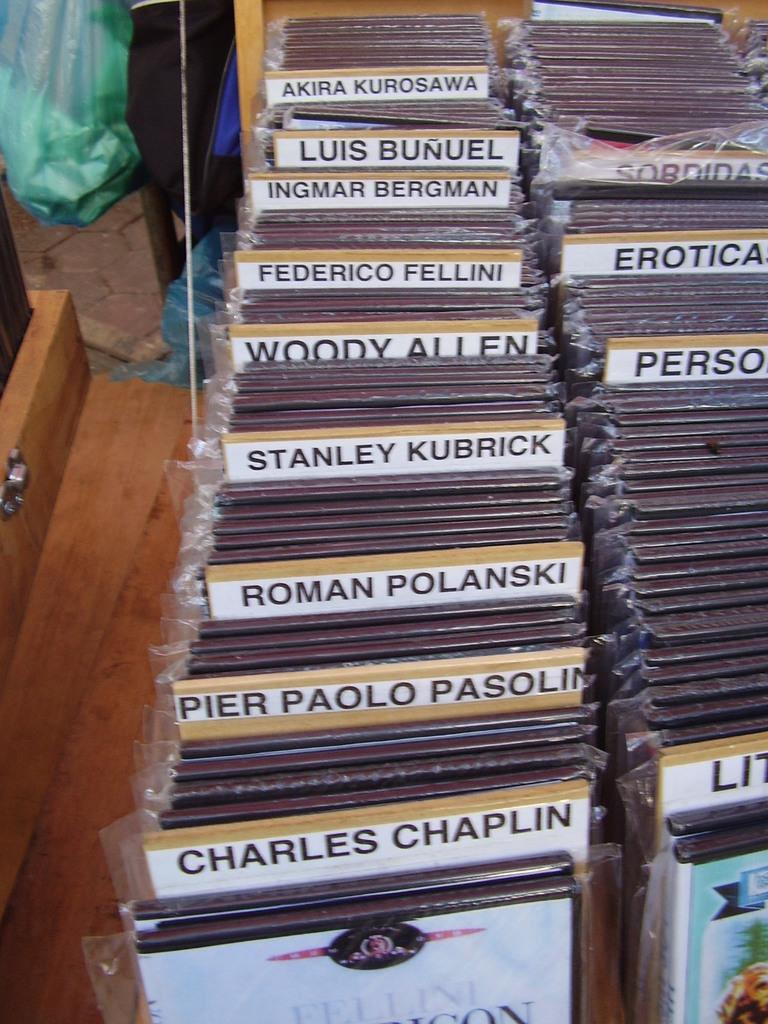<image>
Summarize the visual content of the image. A collection of DVDs includes Charles Chaplin and Roman Polanski. 